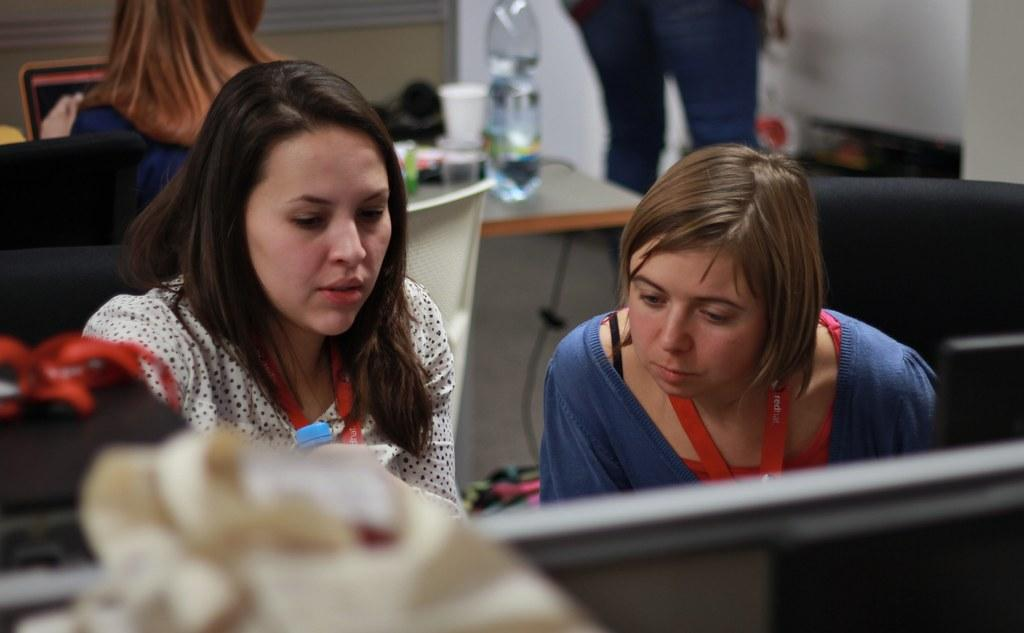How many women are in the image? There are two women in the image. What are the women doing in the image? The women are sitting on chairs. What is present on the table in the image? There is a bottle, a cup, and other objects on the table. Can you describe the background of the image? There are two persons and a wall in the background of the image. What type of reward is the cow receiving in the image? There is no cow present in the image, so it is not possible to determine if a reward is being given or received. 